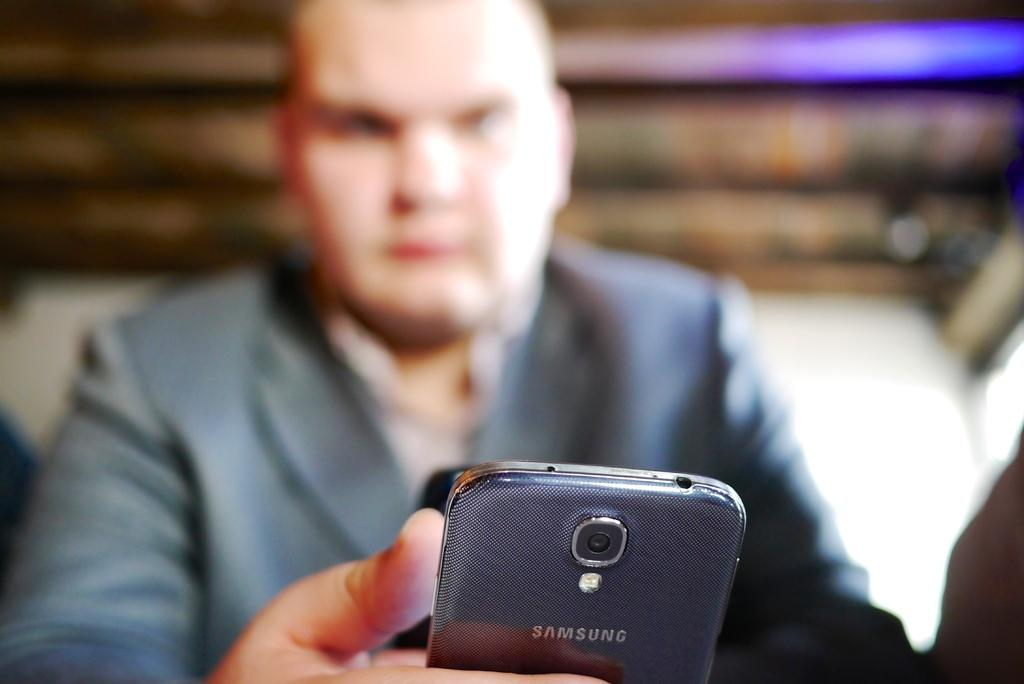What is the main subject of the image? There is a person in the image. What is the person doing in the image? The person is operating a mobile phone. Can you see a gun in the person's hand in the image? No, there is no gun present in the image. Is there a lake visible in the background of the image? No, there is no lake mentioned or visible in the image. 